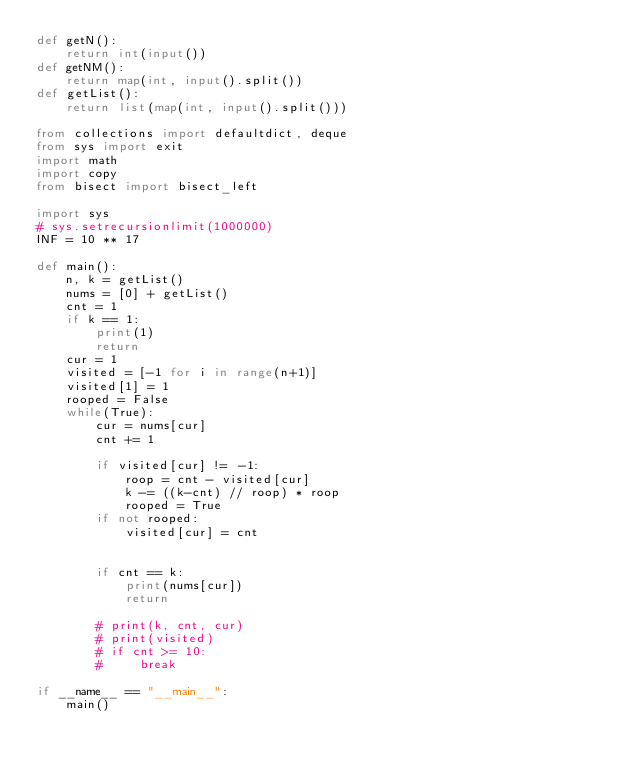<code> <loc_0><loc_0><loc_500><loc_500><_Python_>def getN():
    return int(input())
def getNM():
    return map(int, input().split())
def getList():
    return list(map(int, input().split()))

from collections import defaultdict, deque
from sys import exit
import math
import copy
from bisect import bisect_left

import sys
# sys.setrecursionlimit(1000000)
INF = 10 ** 17

def main():
    n, k = getList()
    nums = [0] + getList()
    cnt = 1
    if k == 1:
        print(1)
        return
    cur = 1
    visited = [-1 for i in range(n+1)]
    visited[1] = 1
    rooped = False
    while(True):
        cur = nums[cur]
        cnt += 1

        if visited[cur] != -1:
            roop = cnt - visited[cur]
            k -= ((k-cnt) // roop) * roop
            rooped = True
        if not rooped:
            visited[cur] = cnt


        if cnt == k:
            print(nums[cur])
            return

        # print(k, cnt, cur)
        # print(visited)
        # if cnt >= 10:
        #     break

if __name__ == "__main__":
    main()

</code> 